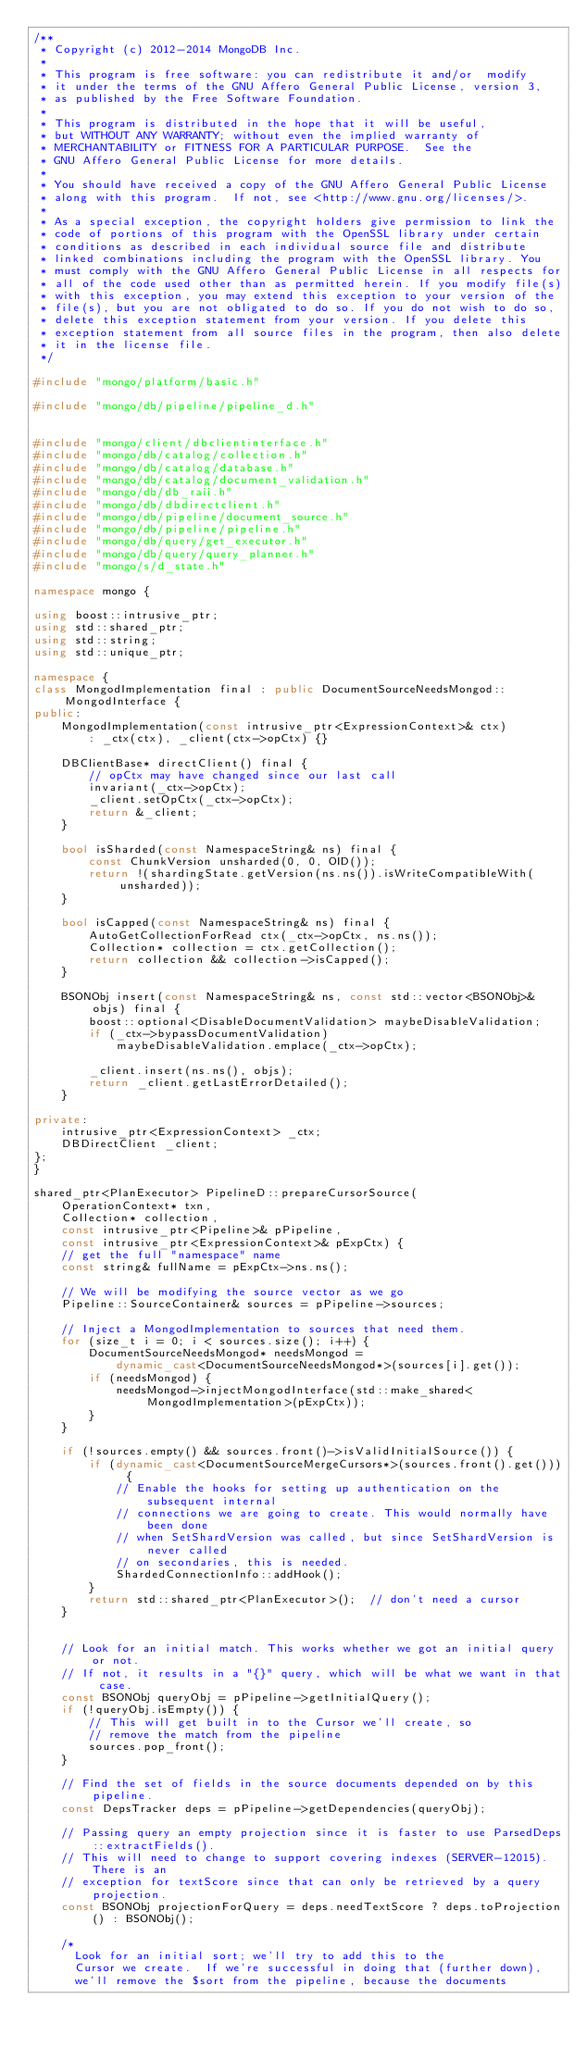<code> <loc_0><loc_0><loc_500><loc_500><_C++_>/**
 * Copyright (c) 2012-2014 MongoDB Inc.
 *
 * This program is free software: you can redistribute it and/or  modify
 * it under the terms of the GNU Affero General Public License, version 3,
 * as published by the Free Software Foundation.
 *
 * This program is distributed in the hope that it will be useful,
 * but WITHOUT ANY WARRANTY; without even the implied warranty of
 * MERCHANTABILITY or FITNESS FOR A PARTICULAR PURPOSE.  See the
 * GNU Affero General Public License for more details.
 *
 * You should have received a copy of the GNU Affero General Public License
 * along with this program.  If not, see <http://www.gnu.org/licenses/>.
 *
 * As a special exception, the copyright holders give permission to link the
 * code of portions of this program with the OpenSSL library under certain
 * conditions as described in each individual source file and distribute
 * linked combinations including the program with the OpenSSL library. You
 * must comply with the GNU Affero General Public License in all respects for
 * all of the code used other than as permitted herein. If you modify file(s)
 * with this exception, you may extend this exception to your version of the
 * file(s), but you are not obligated to do so. If you do not wish to do so,
 * delete this exception statement from your version. If you delete this
 * exception statement from all source files in the program, then also delete
 * it in the license file.
 */

#include "mongo/platform/basic.h"

#include "mongo/db/pipeline/pipeline_d.h"


#include "mongo/client/dbclientinterface.h"
#include "mongo/db/catalog/collection.h"
#include "mongo/db/catalog/database.h"
#include "mongo/db/catalog/document_validation.h"
#include "mongo/db/db_raii.h"
#include "mongo/db/dbdirectclient.h"
#include "mongo/db/pipeline/document_source.h"
#include "mongo/db/pipeline/pipeline.h"
#include "mongo/db/query/get_executor.h"
#include "mongo/db/query/query_planner.h"
#include "mongo/s/d_state.h"

namespace mongo {

using boost::intrusive_ptr;
using std::shared_ptr;
using std::string;
using std::unique_ptr;

namespace {
class MongodImplementation final : public DocumentSourceNeedsMongod::MongodInterface {
public:
    MongodImplementation(const intrusive_ptr<ExpressionContext>& ctx)
        : _ctx(ctx), _client(ctx->opCtx) {}

    DBClientBase* directClient() final {
        // opCtx may have changed since our last call
        invariant(_ctx->opCtx);
        _client.setOpCtx(_ctx->opCtx);
        return &_client;
    }

    bool isSharded(const NamespaceString& ns) final {
        const ChunkVersion unsharded(0, 0, OID());
        return !(shardingState.getVersion(ns.ns()).isWriteCompatibleWith(unsharded));
    }

    bool isCapped(const NamespaceString& ns) final {
        AutoGetCollectionForRead ctx(_ctx->opCtx, ns.ns());
        Collection* collection = ctx.getCollection();
        return collection && collection->isCapped();
    }

    BSONObj insert(const NamespaceString& ns, const std::vector<BSONObj>& objs) final {
        boost::optional<DisableDocumentValidation> maybeDisableValidation;
        if (_ctx->bypassDocumentValidation)
            maybeDisableValidation.emplace(_ctx->opCtx);

        _client.insert(ns.ns(), objs);
        return _client.getLastErrorDetailed();
    }

private:
    intrusive_ptr<ExpressionContext> _ctx;
    DBDirectClient _client;
};
}

shared_ptr<PlanExecutor> PipelineD::prepareCursorSource(
    OperationContext* txn,
    Collection* collection,
    const intrusive_ptr<Pipeline>& pPipeline,
    const intrusive_ptr<ExpressionContext>& pExpCtx) {
    // get the full "namespace" name
    const string& fullName = pExpCtx->ns.ns();

    // We will be modifying the source vector as we go
    Pipeline::SourceContainer& sources = pPipeline->sources;

    // Inject a MongodImplementation to sources that need them.
    for (size_t i = 0; i < sources.size(); i++) {
        DocumentSourceNeedsMongod* needsMongod =
            dynamic_cast<DocumentSourceNeedsMongod*>(sources[i].get());
        if (needsMongod) {
            needsMongod->injectMongodInterface(std::make_shared<MongodImplementation>(pExpCtx));
        }
    }

    if (!sources.empty() && sources.front()->isValidInitialSource()) {
        if (dynamic_cast<DocumentSourceMergeCursors*>(sources.front().get())) {
            // Enable the hooks for setting up authentication on the subsequent internal
            // connections we are going to create. This would normally have been done
            // when SetShardVersion was called, but since SetShardVersion is never called
            // on secondaries, this is needed.
            ShardedConnectionInfo::addHook();
        }
        return std::shared_ptr<PlanExecutor>();  // don't need a cursor
    }


    // Look for an initial match. This works whether we got an initial query or not.
    // If not, it results in a "{}" query, which will be what we want in that case.
    const BSONObj queryObj = pPipeline->getInitialQuery();
    if (!queryObj.isEmpty()) {
        // This will get built in to the Cursor we'll create, so
        // remove the match from the pipeline
        sources.pop_front();
    }

    // Find the set of fields in the source documents depended on by this pipeline.
    const DepsTracker deps = pPipeline->getDependencies(queryObj);

    // Passing query an empty projection since it is faster to use ParsedDeps::extractFields().
    // This will need to change to support covering indexes (SERVER-12015). There is an
    // exception for textScore since that can only be retrieved by a query projection.
    const BSONObj projectionForQuery = deps.needTextScore ? deps.toProjection() : BSONObj();

    /*
      Look for an initial sort; we'll try to add this to the
      Cursor we create.  If we're successful in doing that (further down),
      we'll remove the $sort from the pipeline, because the documents</code> 